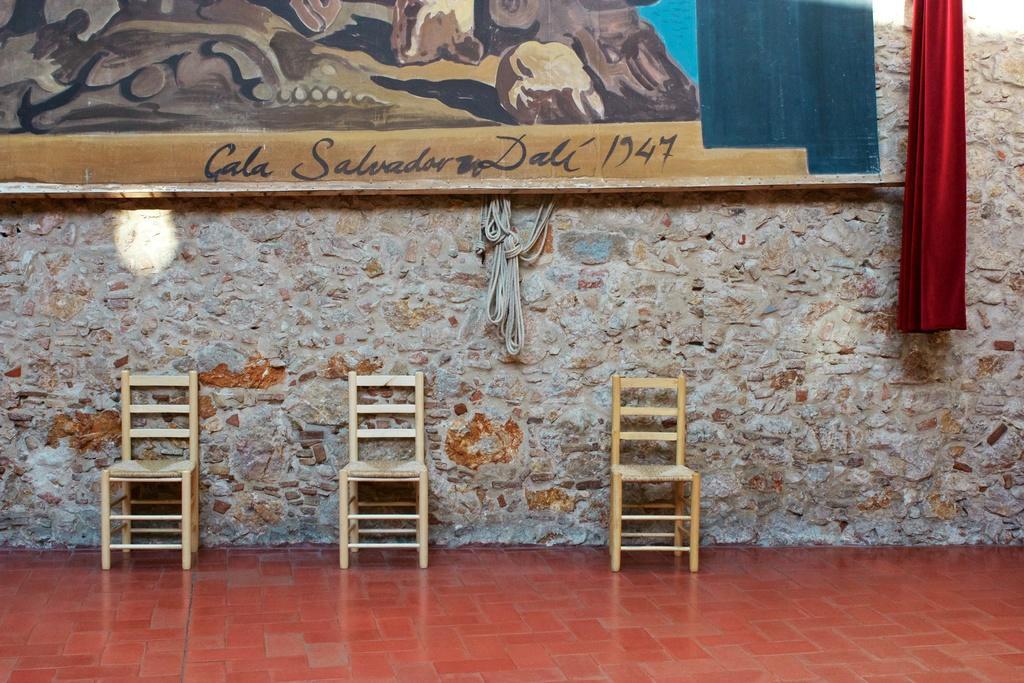<image>
Write a terse but informative summary of the picture. Three wood chairs sit under a large Salvador Dali painting. 